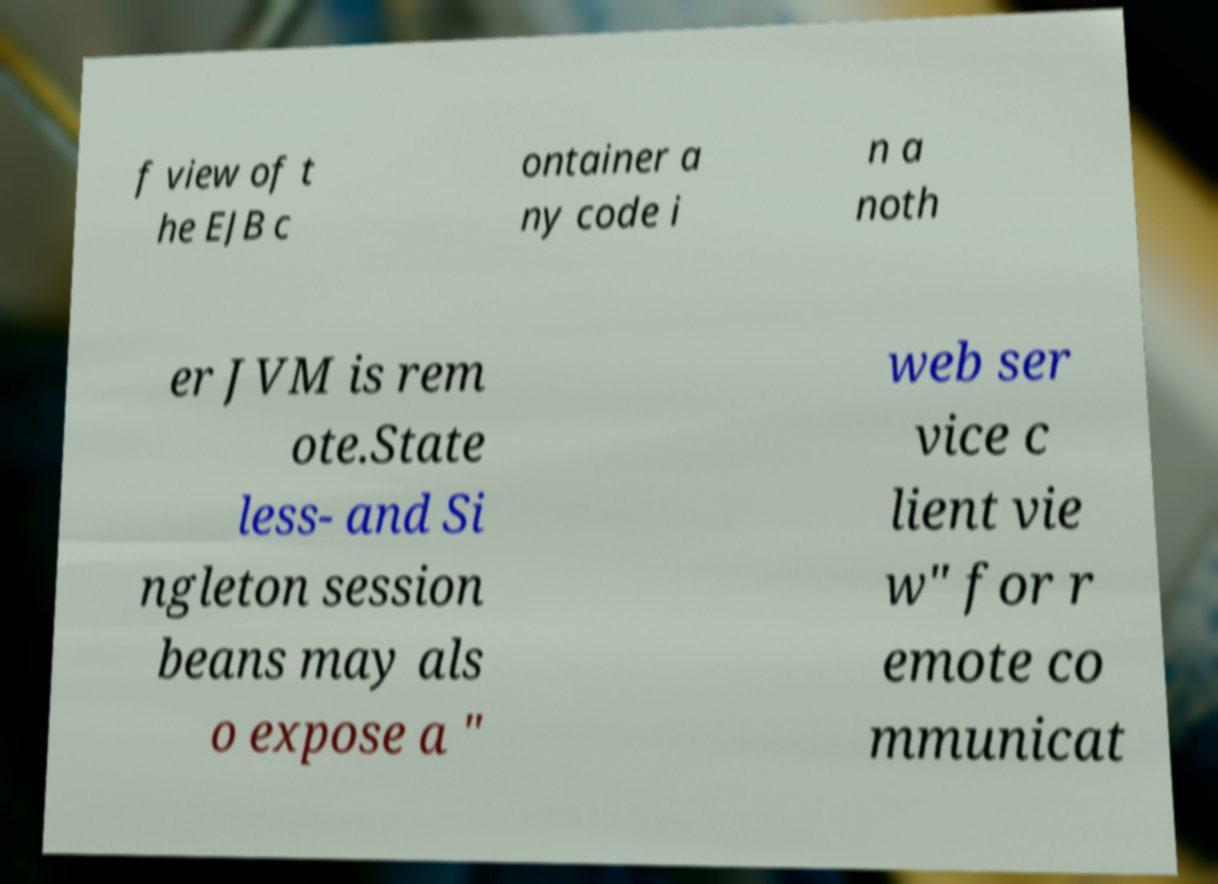Could you assist in decoding the text presented in this image and type it out clearly? f view of t he EJB c ontainer a ny code i n a noth er JVM is rem ote.State less- and Si ngleton session beans may als o expose a " web ser vice c lient vie w" for r emote co mmunicat 